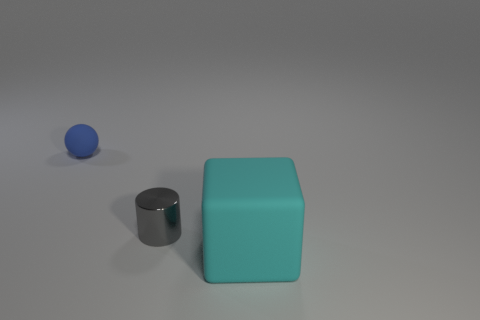Add 2 yellow balls. How many objects exist? 5 Subtract all cylinders. How many objects are left? 2 Add 2 metal things. How many metal things are left? 3 Add 2 large cyan matte things. How many large cyan matte things exist? 3 Subtract 1 blue balls. How many objects are left? 2 Subtract all big cyan cylinders. Subtract all tiny metal cylinders. How many objects are left? 2 